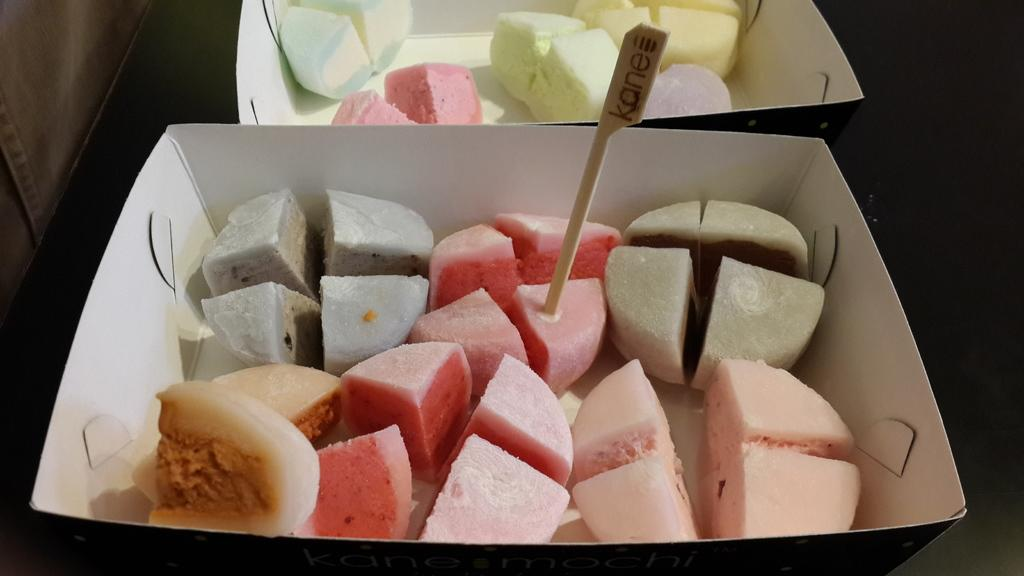What type of containers are present in the image? There are sweet boxes containing sweets in the image. What object is located in the middle of the image? There is a wooden pick in the middle of the image. What color is the background of the image? The background of the image is black in color. What color is the left side of the image? The left side of the image is grey in color. What is the opinion of the sweet boxes on the effect of climate change in the image? There is no indication in the image that the sweet boxes have an opinion on the effect of climate change, as they are inanimate objects. 